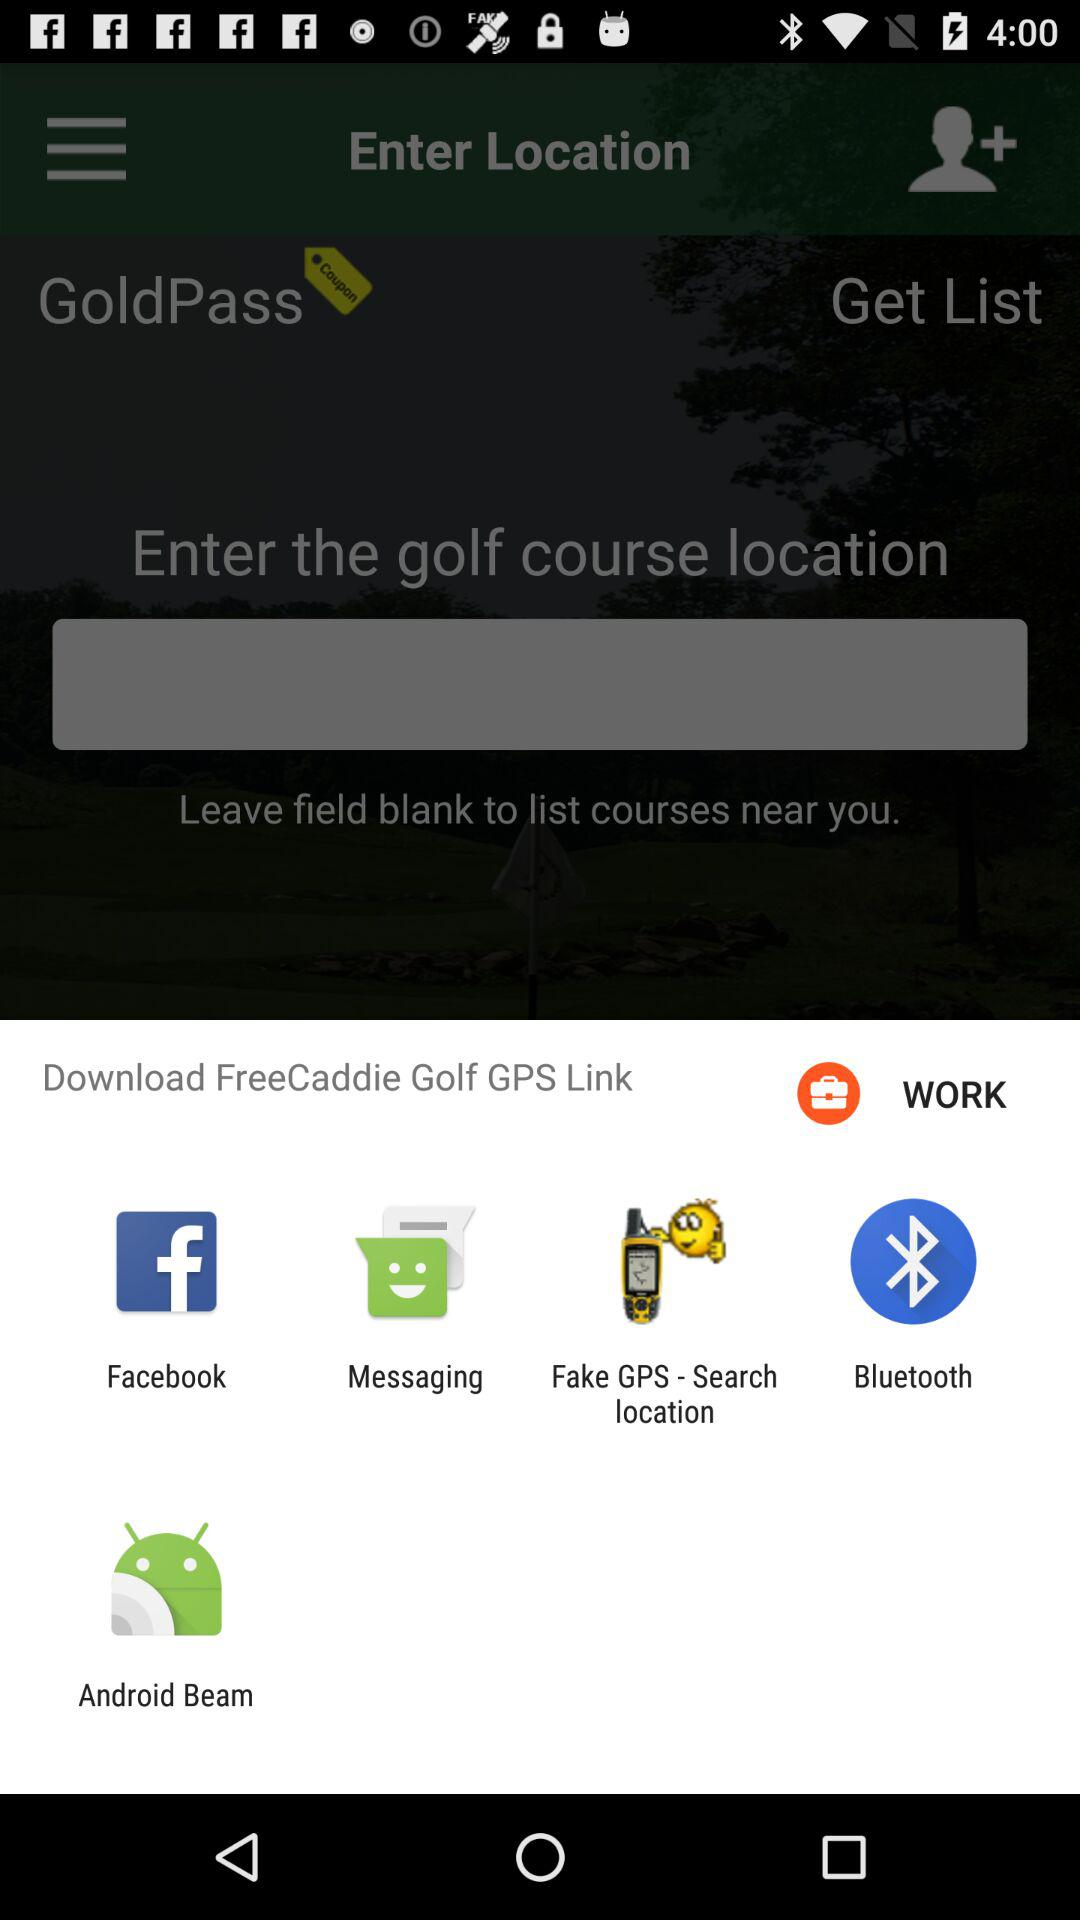Which options are given for downloading? The given options for downloading are "Facebook", "Messaging", "Fake GPS - Search location", "Bluetooth" and "Android Beam". 